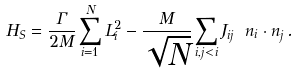<formula> <loc_0><loc_0><loc_500><loc_500>H _ { S } = \frac { \Gamma } { 2 M } \sum _ { i = 1 } ^ { N } L _ { i } ^ { 2 } - \frac { M } { \sqrt { N } } \sum _ { i , j < i } J _ { i j } \ n _ { i } \cdot n _ { j } \, .</formula> 